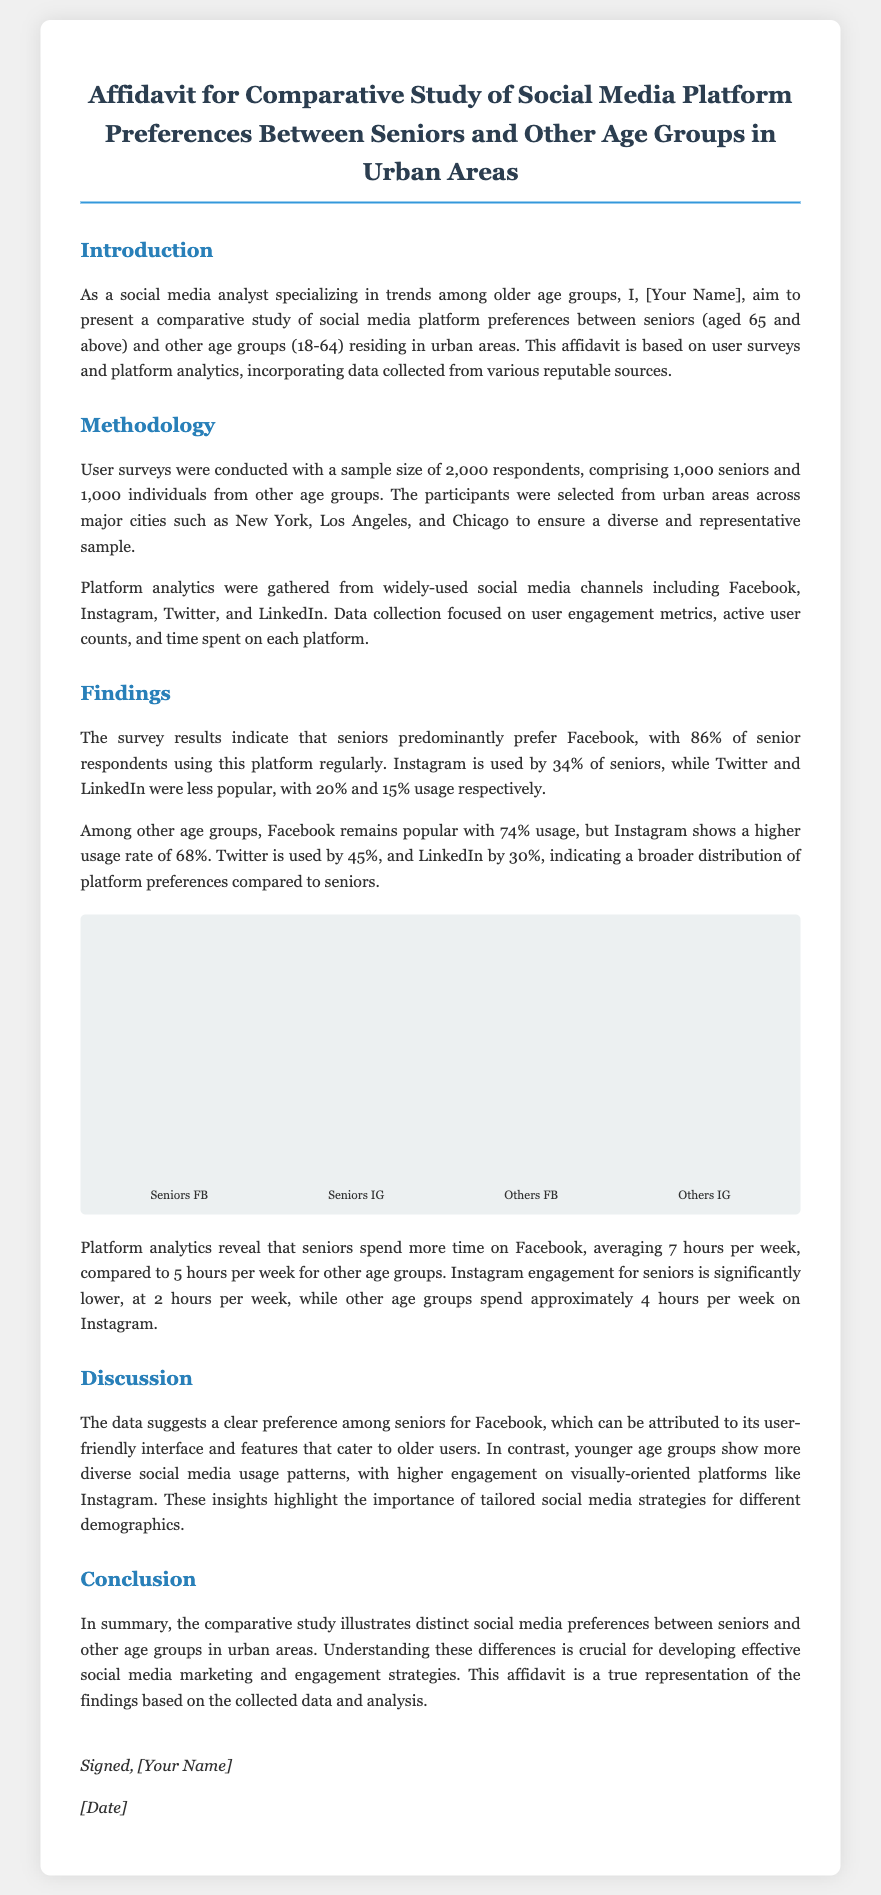what is the focus age group for the study? The focus age group for the study is seniors aged 65 and above.
Answer: seniors how many respondents were surveyed? The total number of respondents surveyed was 2,000.
Answer: 2,000 which social media platform has the highest usage among seniors? The social media platform with the highest usage among seniors is Facebook.
Answer: Facebook what percentage of seniors use Instagram? The percentage of seniors who use Instagram is 34%.
Answer: 34% how many hours per week do seniors spend on Facebook? Seniors spend an average of 7 hours per week on Facebook.
Answer: 7 hours what is the average time spent on Instagram by other age groups? The average time spent on Instagram by other age groups is approximately 4 hours per week.
Answer: 4 hours which platform shows a higher usage rate among younger age groups compared to seniors? The platform that shows a higher usage rate among younger age groups compared to seniors is Instagram.
Answer: Instagram who is the author of the affidavit? The author of the affidavit is [Your Name].
Answer: [Your Name] on what date was the affidavit signed? The date the affidavit was signed is represented as [Date].
Answer: [Date] what does this affidavit represent? This affidavit represents the findings based on the collected data and analysis.
Answer: findings 